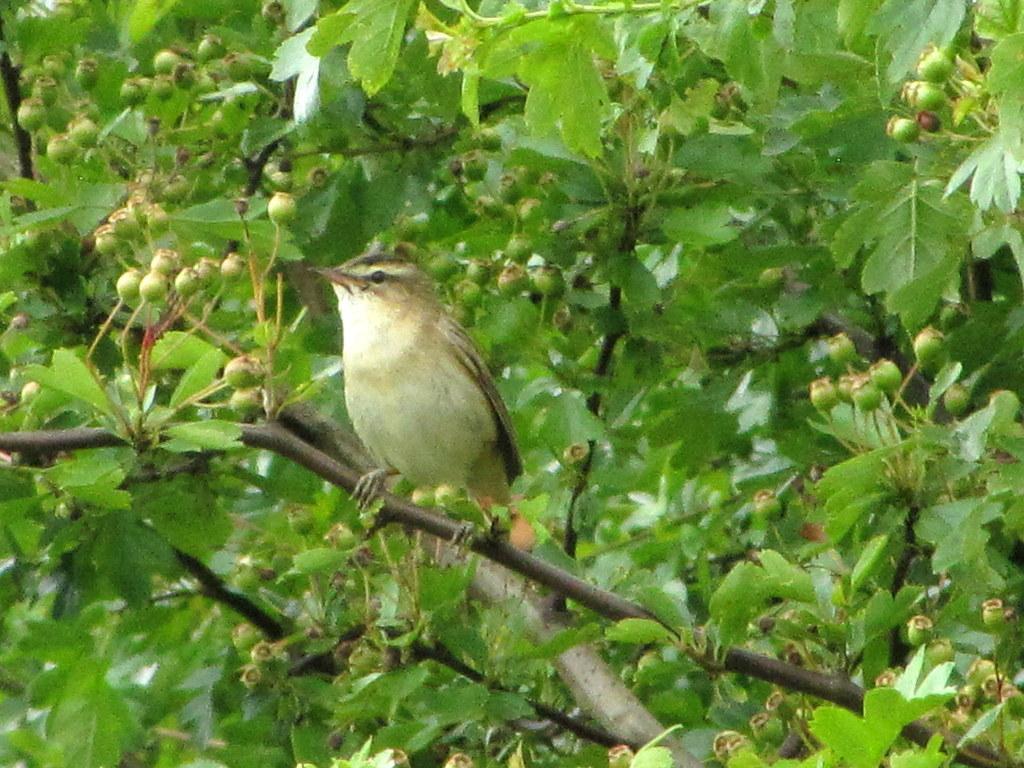Could you give a brief overview of what you see in this image? In this picture I can see a bird on the tree branch and I can see leaves and few buds. 